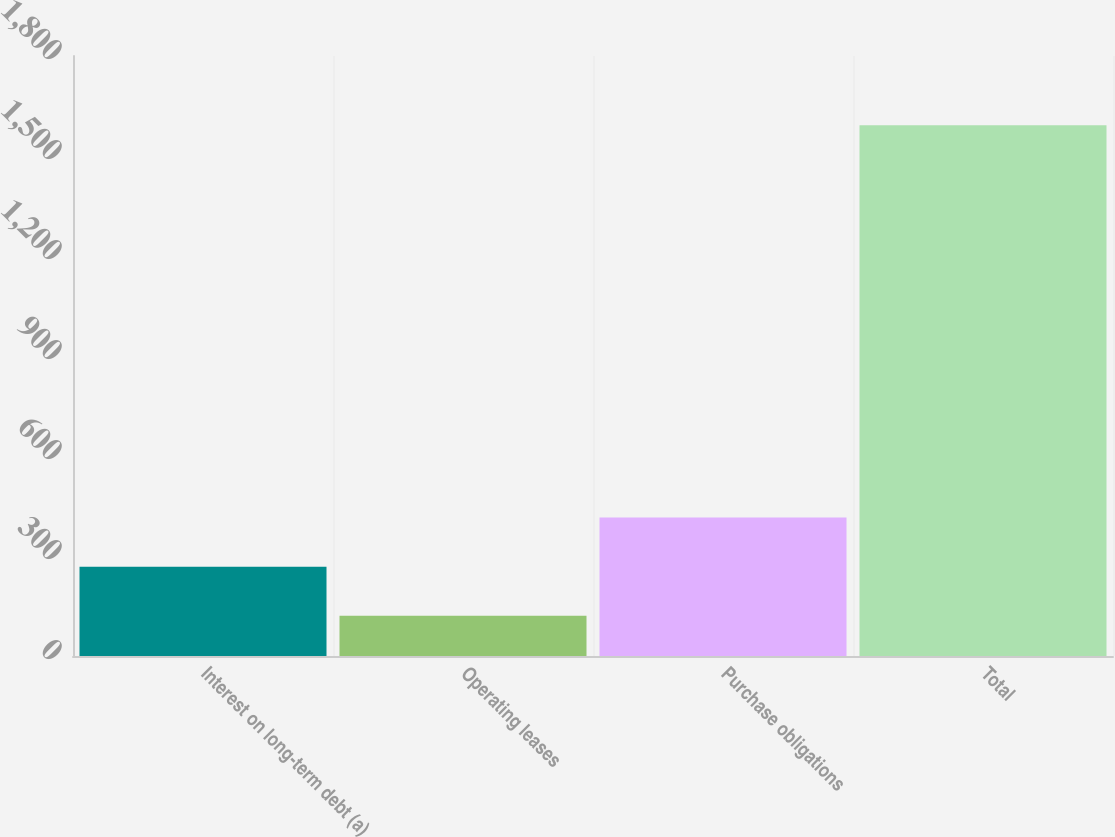<chart> <loc_0><loc_0><loc_500><loc_500><bar_chart><fcel>Interest on long-term debt (a)<fcel>Operating leases<fcel>Purchase obligations<fcel>Total<nl><fcel>268.1<fcel>121<fcel>415.2<fcel>1592<nl></chart> 